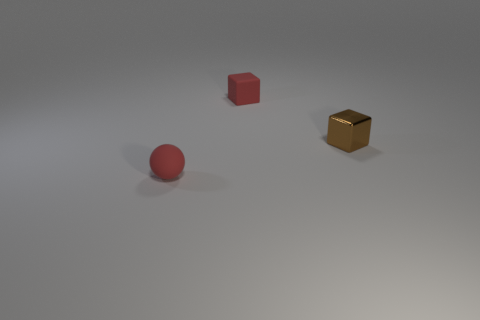There is a thing that is both behind the small red ball and left of the tiny brown thing; what is its shape? The object you're referring to is indeed a cube. It's positioned in a visually interesting manner: behind the small red sphere and to the left of the tiny brown cube, which creates a dynamic spatial composition. 